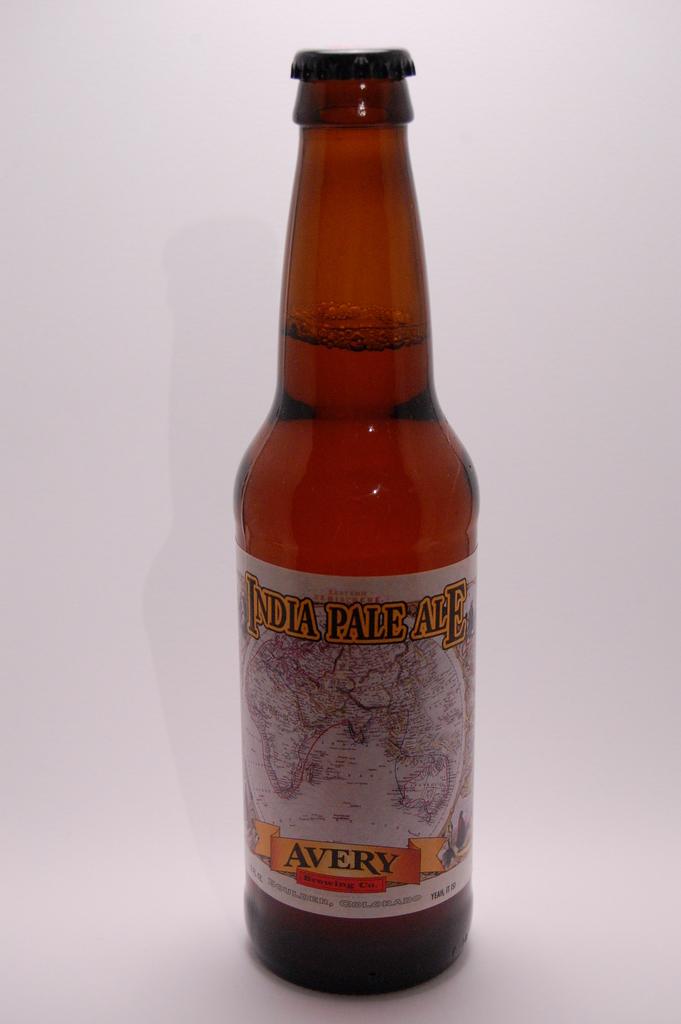What is the brand of ale?
Your answer should be compact. Avery. 